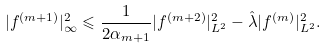Convert formula to latex. <formula><loc_0><loc_0><loc_500><loc_500>| f ^ { ( m + 1 ) } | _ { \infty } ^ { 2 } \leqslant \frac { 1 } { 2 \alpha _ { m + 1 } } | f ^ { ( m + 2 ) } | _ { L ^ { 2 } } ^ { 2 } - \hat { \lambda } | f ^ { ( m ) } | _ { L ^ { 2 } } ^ { 2 } .</formula> 